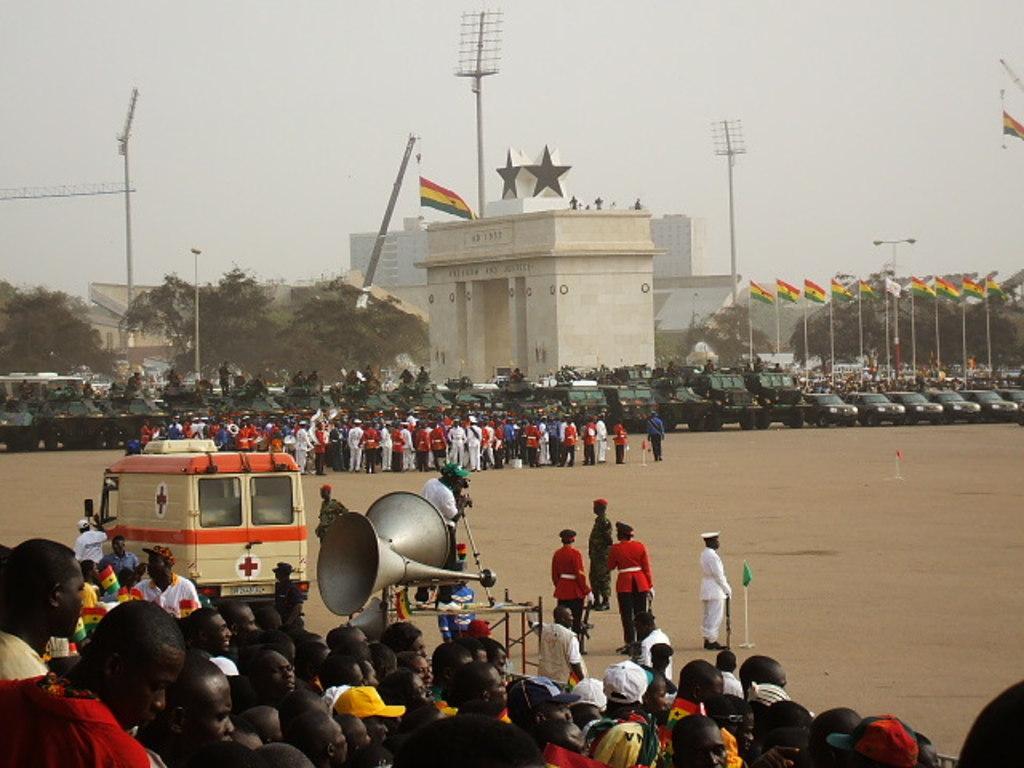Describe this image in one or two sentences. In this picture I can see flags with poles, lights, vehicles, megaphones, group of people, cranes, trees, buildings, and in the background there is sky. 